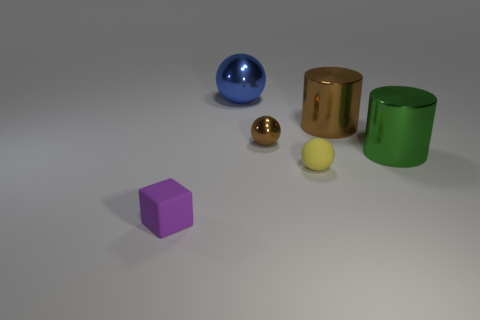Subtract all yellow balls. How many balls are left? 2 Subtract all shiny balls. How many balls are left? 1 Subtract all cylinders. How many objects are left? 4 Subtract all red cubes. How many brown cylinders are left? 1 Subtract 0 green blocks. How many objects are left? 6 Subtract 1 cylinders. How many cylinders are left? 1 Subtract all yellow balls. Subtract all red cylinders. How many balls are left? 2 Subtract all big green cylinders. Subtract all red balls. How many objects are left? 5 Add 5 big blue metallic things. How many big blue metallic things are left? 6 Add 6 small cyan balls. How many small cyan balls exist? 6 